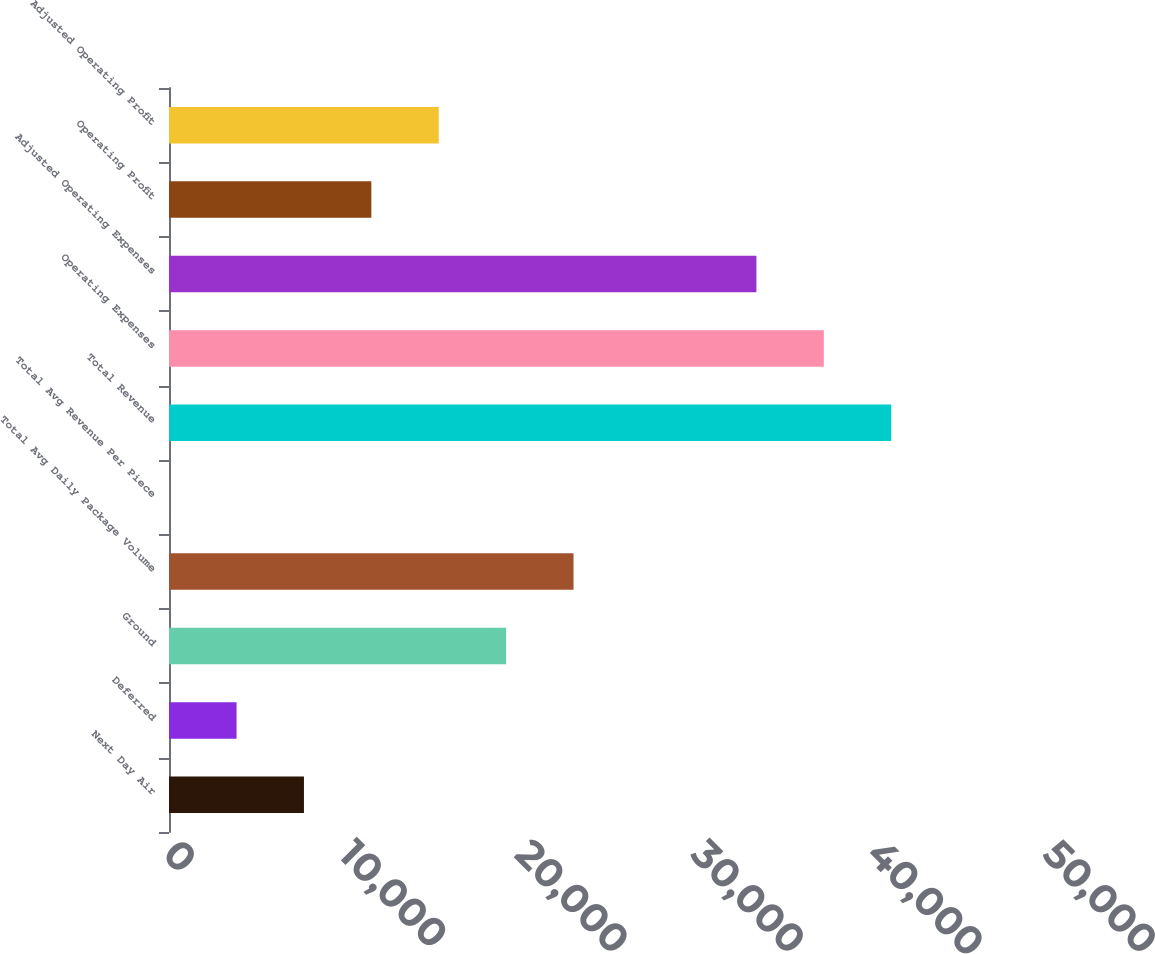Convert chart. <chart><loc_0><loc_0><loc_500><loc_500><bar_chart><fcel>Next Day Air<fcel>Deferred<fcel>Ground<fcel>Total Avg Daily Package Volume<fcel>Total Avg Revenue Per Piece<fcel>Total Revenue<fcel>Operating Expenses<fcel>Adjusted Operating Expenses<fcel>Operating Profit<fcel>Adjusted Operating Profit<nl><fcel>7667.6<fcel>3838.43<fcel>19155.1<fcel>22984.3<fcel>9.25<fcel>41034.4<fcel>37205.2<fcel>33376<fcel>11496.8<fcel>15326<nl></chart> 